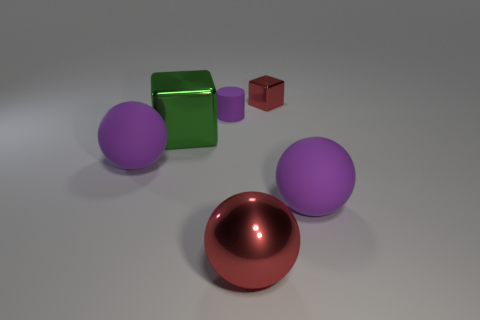What could be the purpose of these objects in the image? The objects in the image seem to be rendered for illustrative or artistic purposes, possibly as a part of a 3D modeling and rendering exercise. Each object's distinct color and material could be meant to demonstrate the application of different textures and lighting effects in 3D design. They aren't representative of functional items but are rather used to showcase visual effects and the capabilities of rendering software. How would you categorize the lighting and mood of the scene? The scene is evenly lit with soft shadows, suggesting a softbox or diffused light source that provides ambient illumination. This creates a neutral atmosphere, neither particularly warm nor cold. The soft lighting contributes to a calm and tranquil mood, which is often used in product visualization to focus attention on the objects themselves without the influence of dramatic or expressive lighting. 